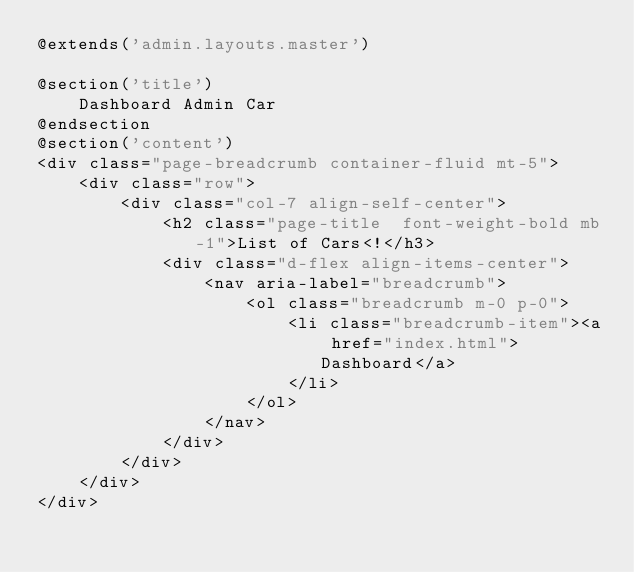<code> <loc_0><loc_0><loc_500><loc_500><_PHP_>@extends('admin.layouts.master')

@section('title')
    Dashboard Admin Car
@endsection
@section('content')
<div class="page-breadcrumb container-fluid mt-5">
    <div class="row">
        <div class="col-7 align-self-center">
            <h2 class="page-title  font-weight-bold mb-1">List of Cars<!</h3>
            <div class="d-flex align-items-center">
                <nav aria-label="breadcrumb">
                    <ol class="breadcrumb m-0 p-0">
                        <li class="breadcrumb-item"><a href="index.html">Dashboard</a>
                        </li>
                    </ol>
                </nav>
            </div>
        </div>
    </div>
</div></code> 